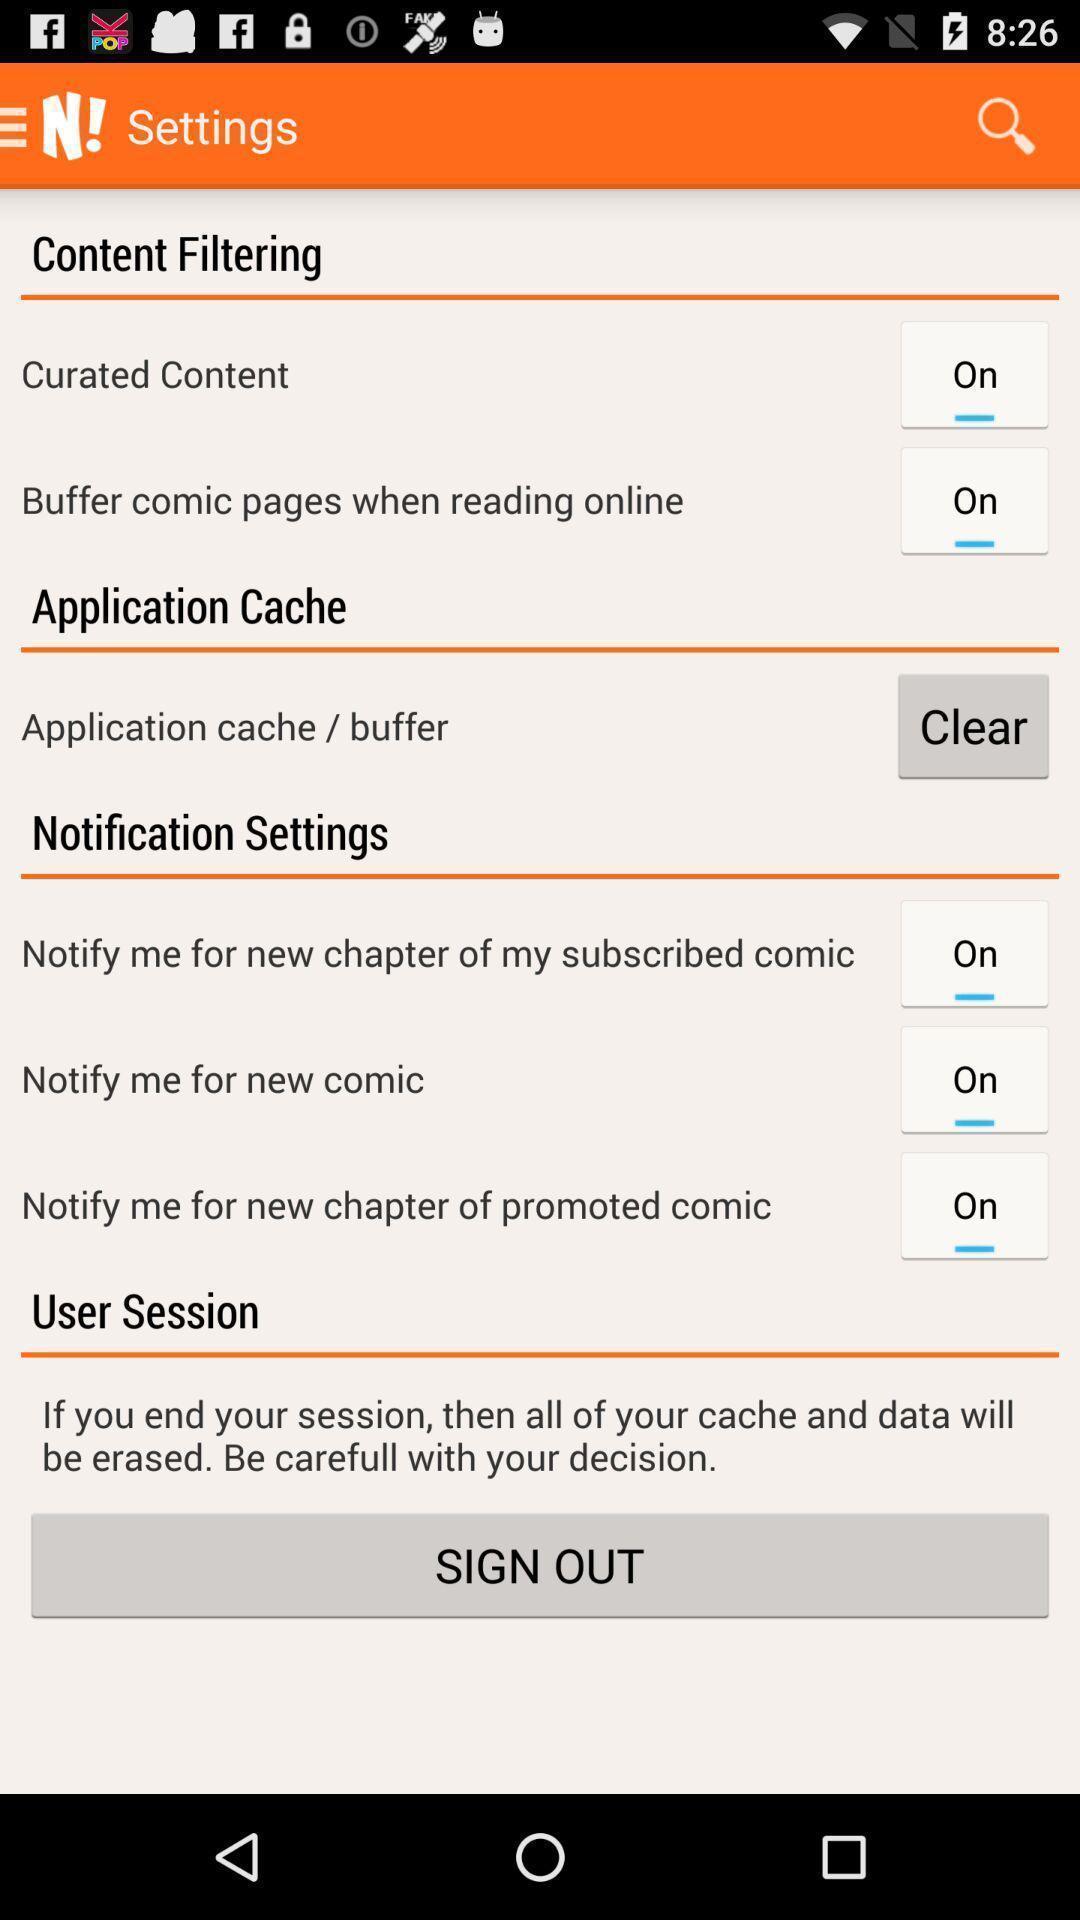Give me a narrative description of this picture. Settings page displayed of a ebook reading app. 